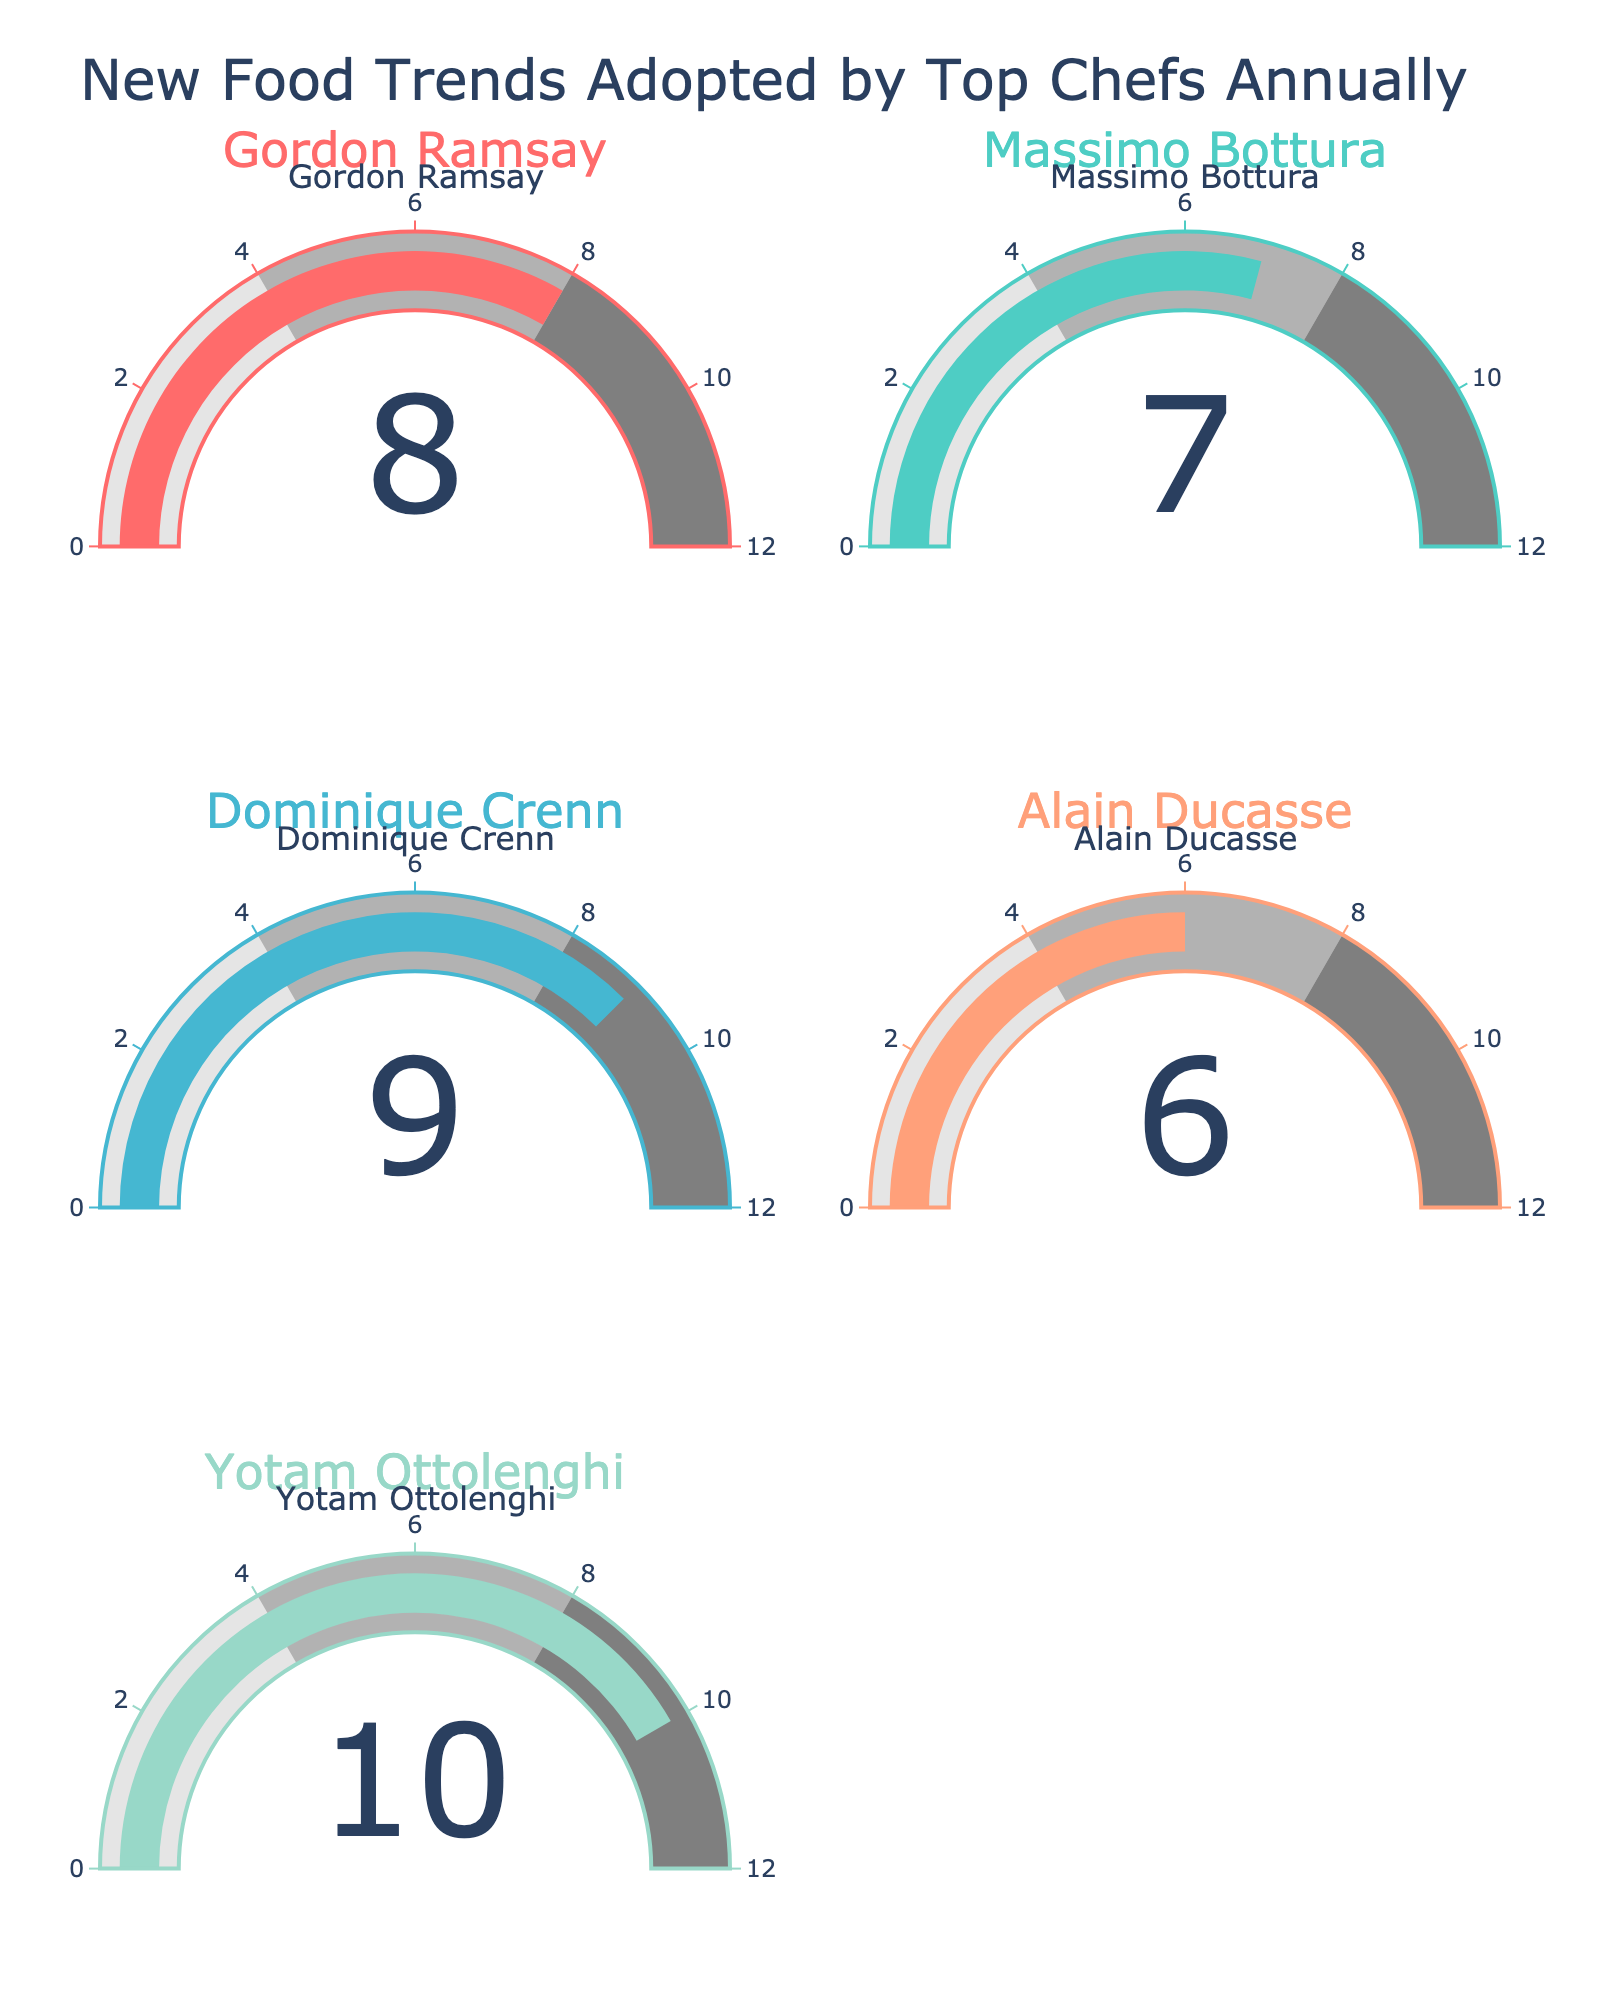What's the title of the figure? The title is at the top of the figure and reads "New Food Trends Adopted by Top Chefs Annually".
Answer: New Food Trends Adopted by Top Chefs Annually How many chefs are shown in the figure? By counting the number of subplots, each titled with a chef's name, we can see there are five chefs.
Answer: Five Which chef has adopted the highest number of new food trends? Refer to the gauge values displayed in each subplot. The highest value shown is 10, which is adopted by Yotam Ottolenghi.
Answer: Yotam Ottolenghi What is the average number of new food trends adopted by the chefs? Sum the values from each gauge chart and divide by the number of chefs: (8 + 7 + 9 + 6 + 10) / 5 = 40 / 5 = 8.
Answer: 8 Which chefs have adopted more than 8 new food trends? Looking at the gauge values, Dominique Crenn (9) and Yotam Ottolenghi (10) have both adopted more than 8 new food trends.
Answer: Dominique Crenn and Yotam Ottolenghi What is the color of the bar for Gordon Ramsay's gauge? The colors for each chef's bar are unique and visible in their respective subplots. Gordon Ramsay’s bar is the first one and it is red.
Answer: Red Who's adopted 7 new food trends? Look for the gauge showing a value of 7. The title indicates this belongs to Massimo Bottura.
Answer: Massimo Bottura How much more food trends has Yotam Ottolenghi adopted compared to Alain Ducasse? The values are 10 for Yotam Ottolenghi and 6 for Alain Ducasse. Subtract 6 from 10 to find the difference: 10 - 6 = 4.
Answer: 4 What's the range of the gauge scales? Observe the scaling at the edge of each gauge which ranges from 0 to 12.
Answer: 0 to 12 Who are the chefs displayed in the first row of the subplots? The chefs' names can be seen at the top of each subplot. In the first row, they are Gordon Ramsay and Massimo Bottura.
Answer: Gordon Ramsay and Massimo Bottura 